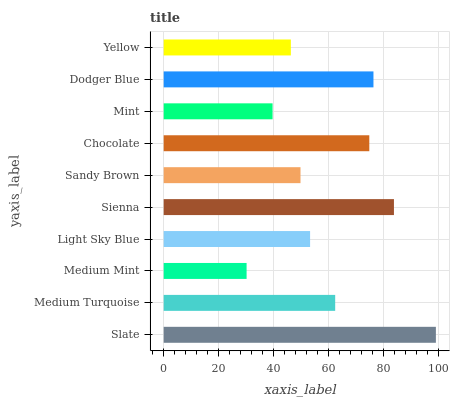Is Medium Mint the minimum?
Answer yes or no. Yes. Is Slate the maximum?
Answer yes or no. Yes. Is Medium Turquoise the minimum?
Answer yes or no. No. Is Medium Turquoise the maximum?
Answer yes or no. No. Is Slate greater than Medium Turquoise?
Answer yes or no. Yes. Is Medium Turquoise less than Slate?
Answer yes or no. Yes. Is Medium Turquoise greater than Slate?
Answer yes or no. No. Is Slate less than Medium Turquoise?
Answer yes or no. No. Is Medium Turquoise the high median?
Answer yes or no. Yes. Is Light Sky Blue the low median?
Answer yes or no. Yes. Is Sienna the high median?
Answer yes or no. No. Is Sienna the low median?
Answer yes or no. No. 